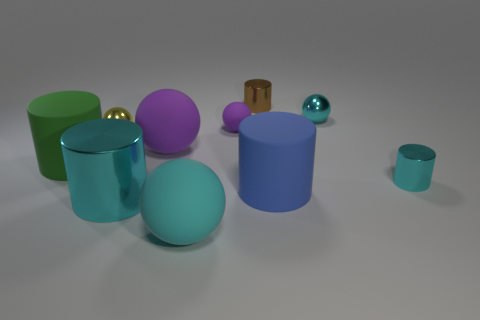What color is the other cylinder that is the same size as the brown metal cylinder?
Ensure brevity in your answer.  Cyan. How many cyan balls are in front of the large metallic object?
Offer a very short reply. 1. Is there a small purple ball?
Your answer should be compact. Yes. How big is the cyan sphere behind the cyan thing in front of the large metallic thing that is on the left side of the brown cylinder?
Your answer should be compact. Small. How many other things are the same size as the green cylinder?
Provide a short and direct response. 4. There is a rubber cylinder on the right side of the cyan matte object; what is its size?
Ensure brevity in your answer.  Large. Are there any other things that are the same color as the big metal cylinder?
Your response must be concise. Yes. Do the tiny yellow sphere in front of the brown cylinder and the small cyan cylinder have the same material?
Provide a succinct answer. Yes. What number of shiny objects are behind the big purple rubber ball and to the right of the blue cylinder?
Give a very brief answer. 1. There is a cyan object that is behind the cyan cylinder to the right of the big purple matte sphere; what is its size?
Give a very brief answer. Small. 